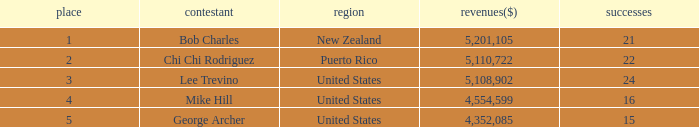What is the lowest level of Earnings($) to have a Wins value of 22 and a Rank lower than 2? None. 